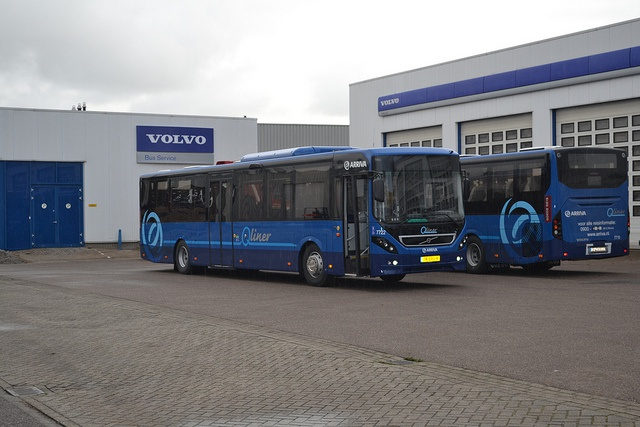Describe the objects in this image and their specific colors. I can see bus in lightgray, black, navy, gray, and darkblue tones and bus in lightgray, black, navy, gray, and darkblue tones in this image. 